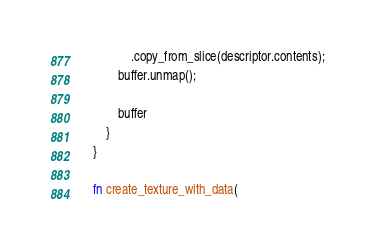<code> <loc_0><loc_0><loc_500><loc_500><_Rust_>                .copy_from_slice(descriptor.contents);
            buffer.unmap();

            buffer
        }
    }

    fn create_texture_with_data(</code> 